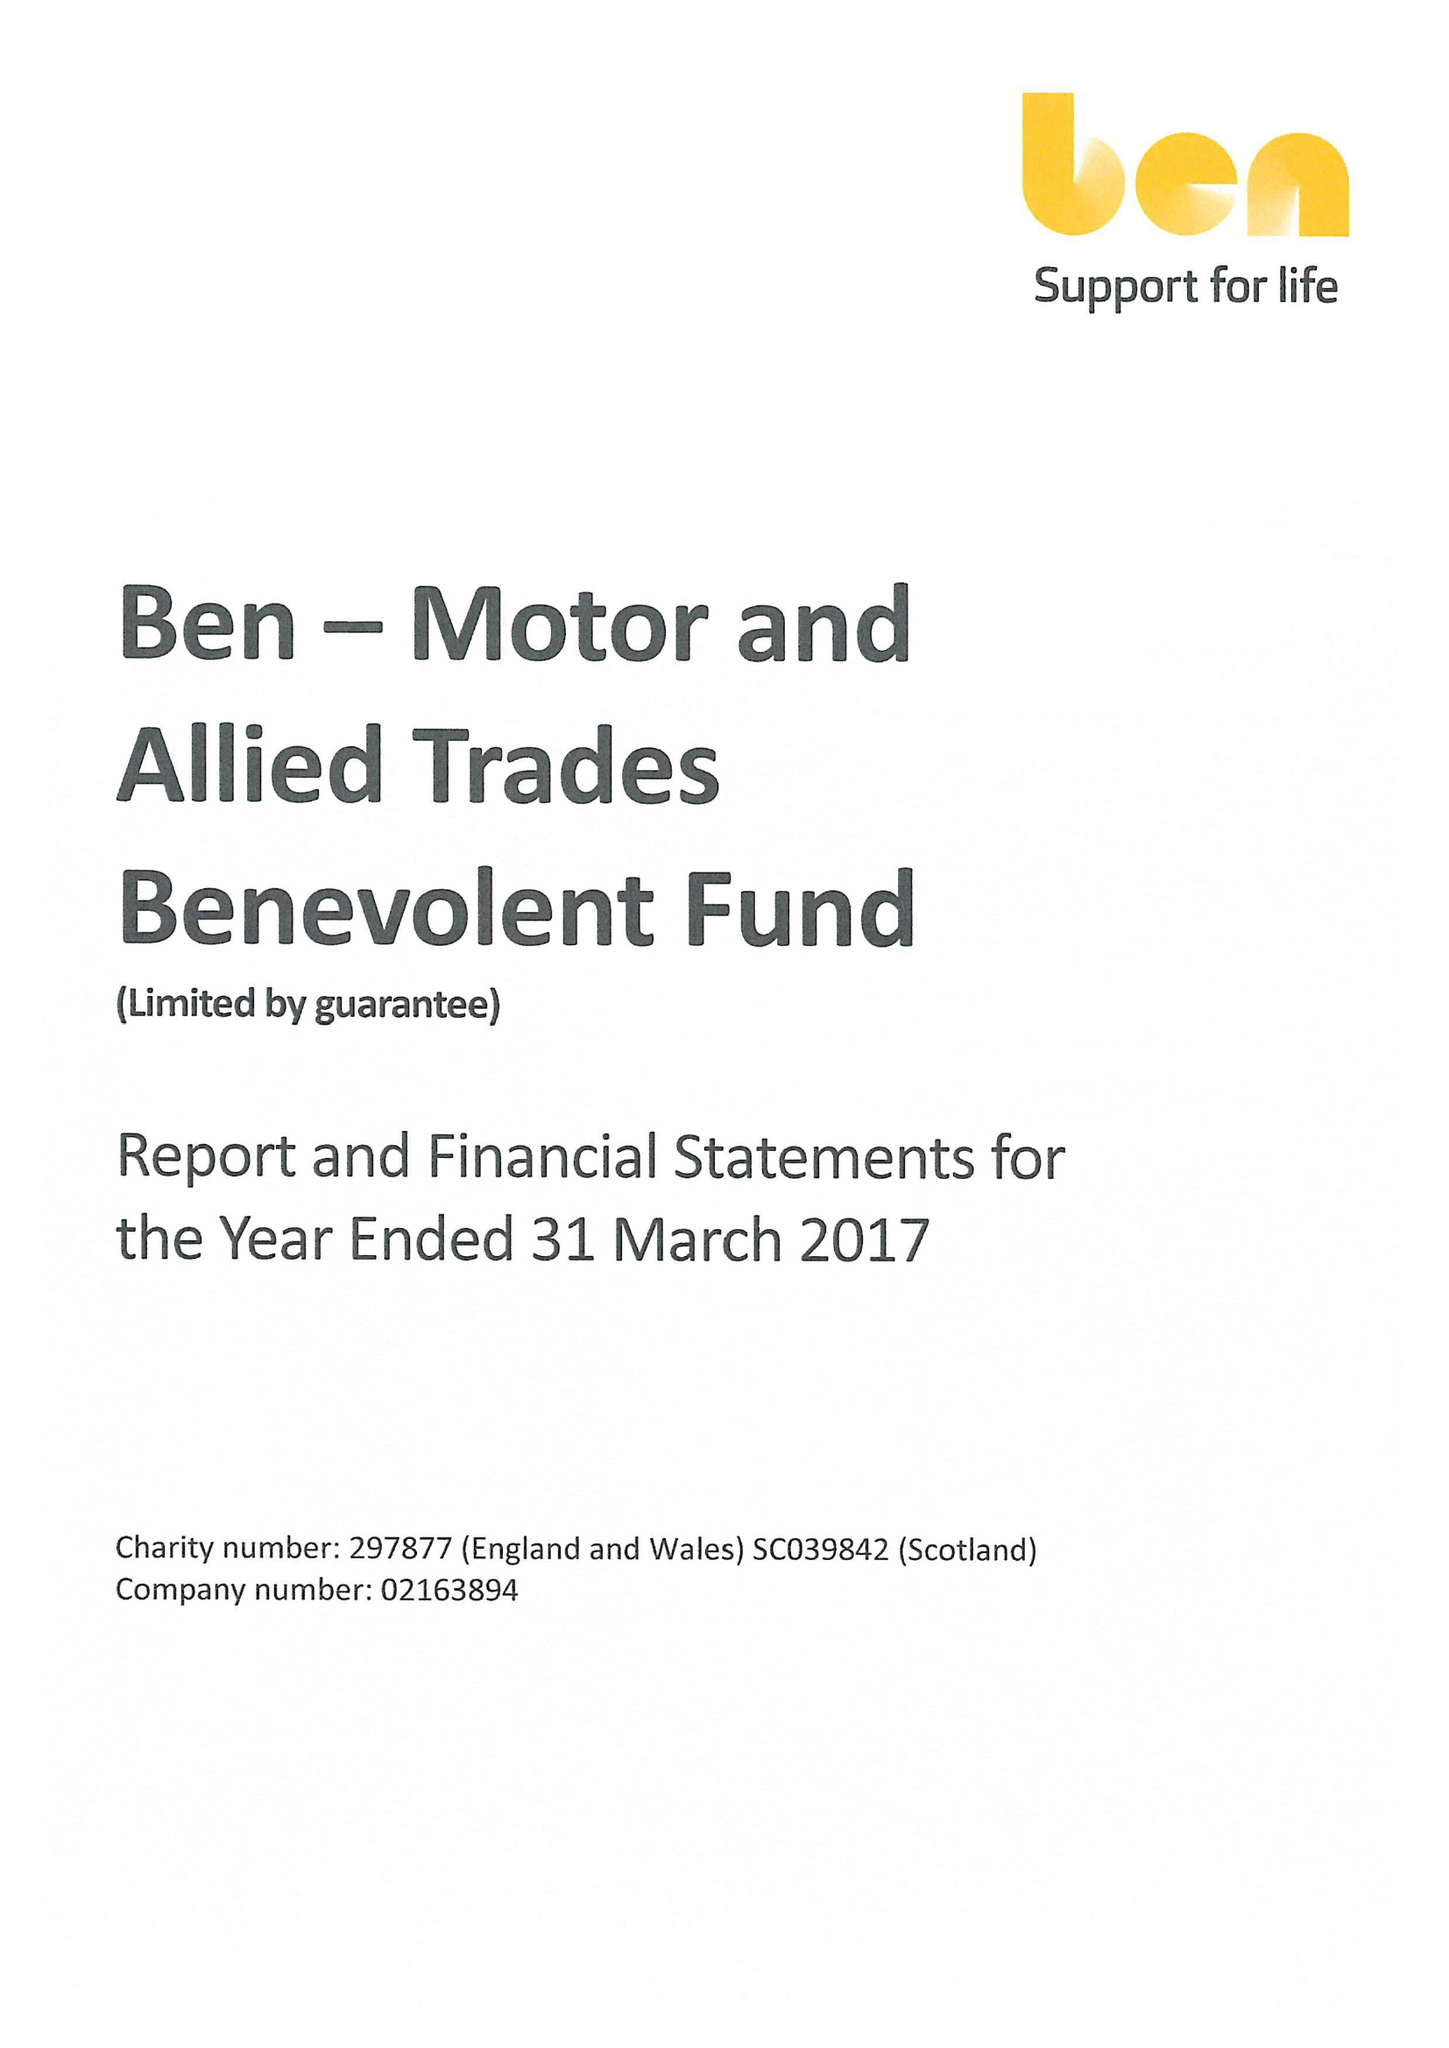What is the value for the charity_name?
Answer the question using a single word or phrase. Ben - Motor and Allied Trades Benevolent Fund 